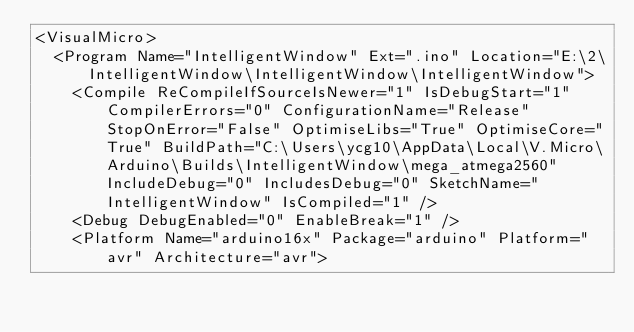<code> <loc_0><loc_0><loc_500><loc_500><_XML_><VisualMicro>
  <Program Name="IntelligentWindow" Ext=".ino" Location="E:\2\IntelligentWindow\IntelligentWindow\IntelligentWindow">
    <Compile ReCompileIfSourceIsNewer="1" IsDebugStart="1" CompilerErrors="0" ConfigurationName="Release" StopOnError="False" OptimiseLibs="True" OptimiseCore="True" BuildPath="C:\Users\ycg10\AppData\Local\V.Micro\Arduino\Builds\IntelligentWindow\mega_atmega2560" IncludeDebug="0" IncludesDebug="0" SketchName="IntelligentWindow" IsCompiled="1" />
    <Debug DebugEnabled="0" EnableBreak="1" />
    <Platform Name="arduino16x" Package="arduino" Platform="avr" Architecture="avr"></code> 